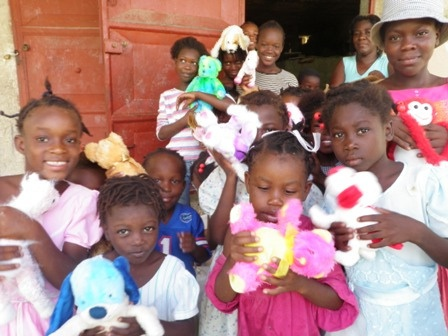Describe the objects in this image and their specific colors. I can see people in tan, brown, violet, white, and magenta tones, people in tan, white, brown, and maroon tones, people in tan, lavender, brown, and salmon tones, people in tan, brown, white, and maroon tones, and people in tan, white, brown, and maroon tones in this image. 